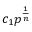<formula> <loc_0><loc_0><loc_500><loc_500>c _ { 1 } p ^ { \frac { 1 } { n } }</formula> 